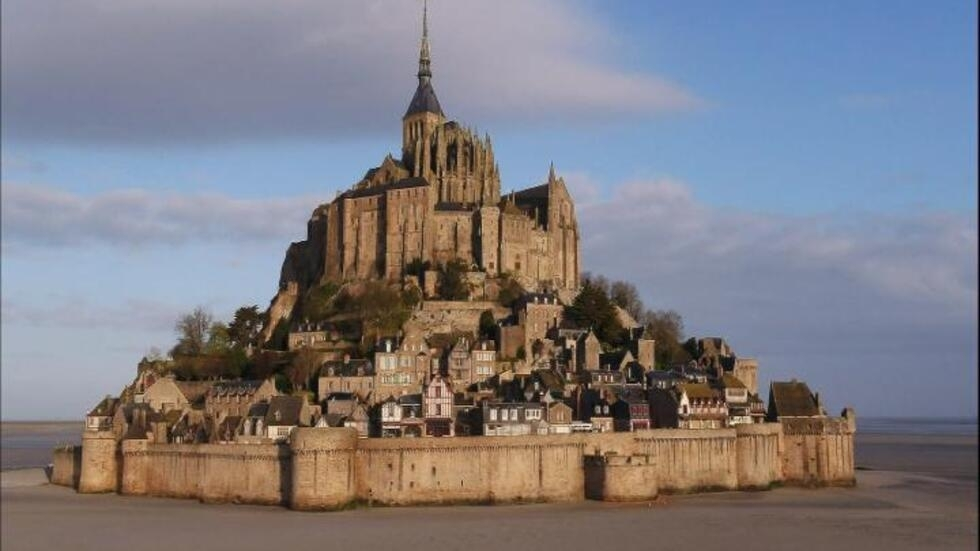Why is Mont St Michel built on an island? Mont St Michel was strategically built on a small rocky island to defend against invasions and attacks during the medieval period. Its location made it accessible only during low tide initially, which naturally protected it from many would-be assailants. Over time, the site also gained a significant religious importance, becoming a pilgrimage site due to its isolation and the perceived closeness to the heavens, amplified by its imposing height and striking presence rising above the tidal flats. 